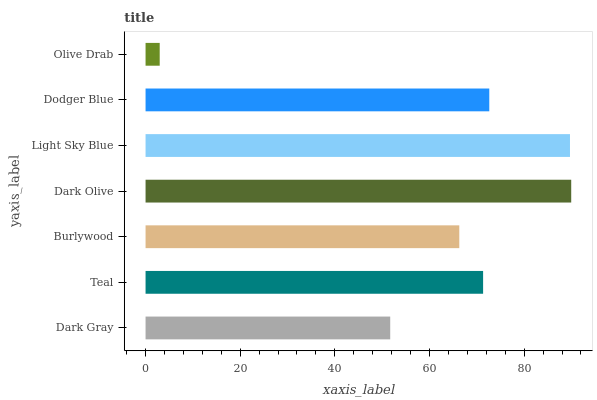Is Olive Drab the minimum?
Answer yes or no. Yes. Is Dark Olive the maximum?
Answer yes or no. Yes. Is Teal the minimum?
Answer yes or no. No. Is Teal the maximum?
Answer yes or no. No. Is Teal greater than Dark Gray?
Answer yes or no. Yes. Is Dark Gray less than Teal?
Answer yes or no. Yes. Is Dark Gray greater than Teal?
Answer yes or no. No. Is Teal less than Dark Gray?
Answer yes or no. No. Is Teal the high median?
Answer yes or no. Yes. Is Teal the low median?
Answer yes or no. Yes. Is Olive Drab the high median?
Answer yes or no. No. Is Dark Olive the low median?
Answer yes or no. No. 